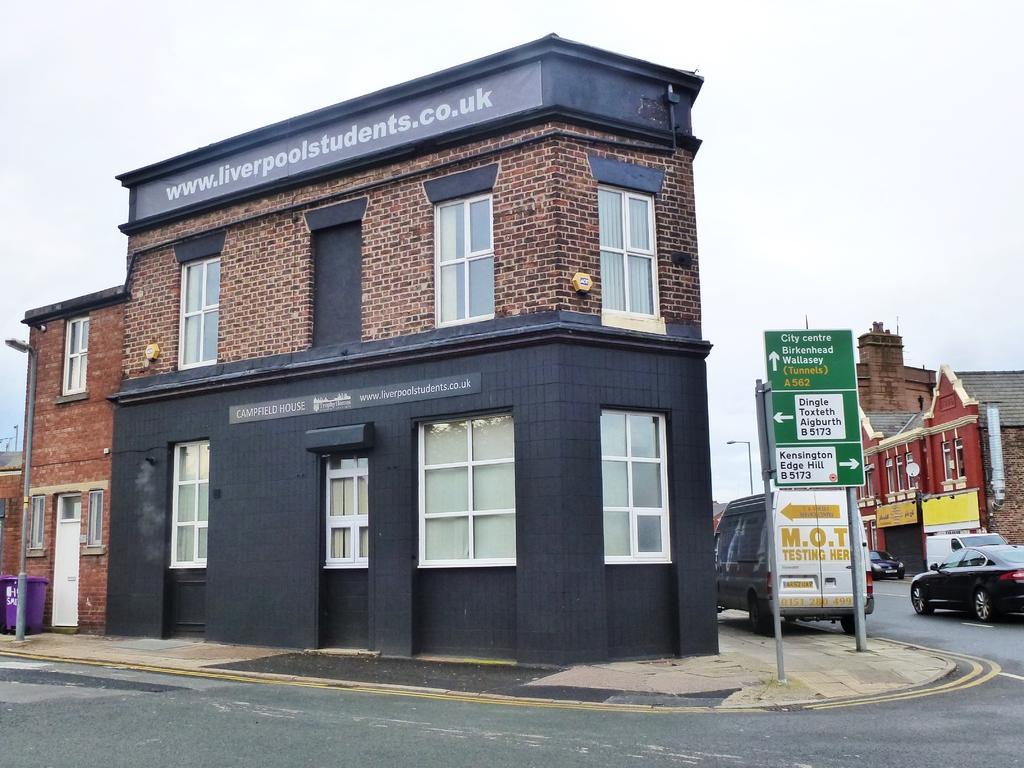Could you give a brief overview of what you see in this image? In the picture we can see a building with glass windows and door and beside it we can see a board with some place indications and behind it we can see two vehicles on the road and a other building and on the other side we can see some houses and in the background we can see the sky. 